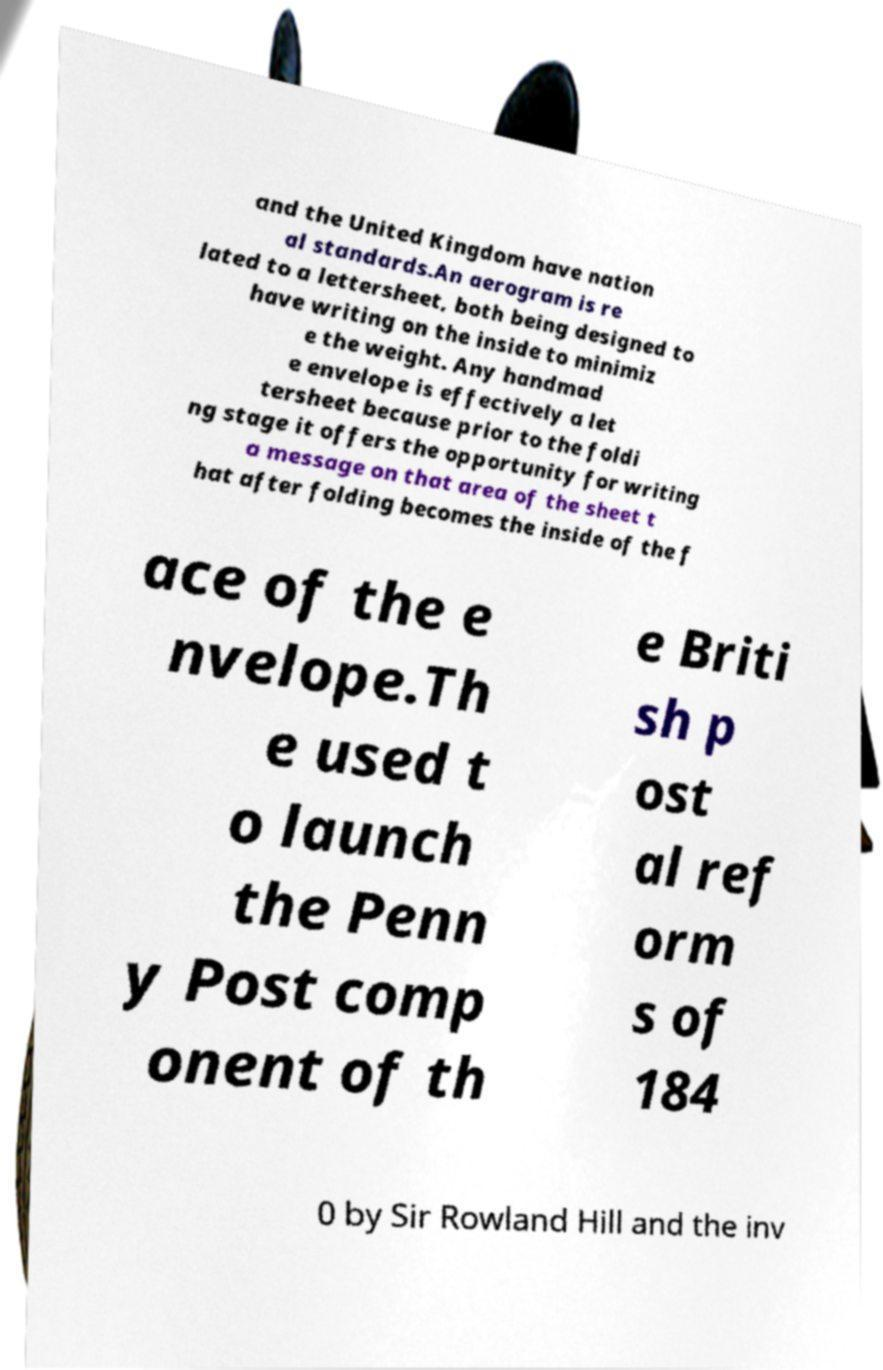Could you extract and type out the text from this image? and the United Kingdom have nation al standards.An aerogram is re lated to a lettersheet, both being designed to have writing on the inside to minimiz e the weight. Any handmad e envelope is effectively a let tersheet because prior to the foldi ng stage it offers the opportunity for writing a message on that area of the sheet t hat after folding becomes the inside of the f ace of the e nvelope.Th e used t o launch the Penn y Post comp onent of th e Briti sh p ost al ref orm s of 184 0 by Sir Rowland Hill and the inv 